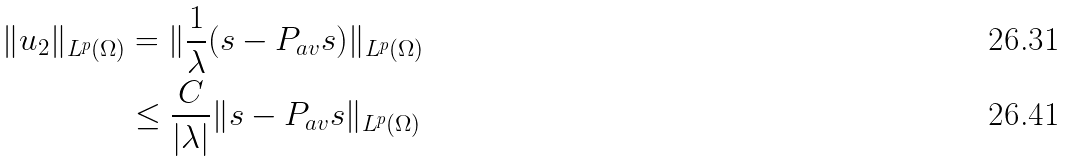<formula> <loc_0><loc_0><loc_500><loc_500>\| u _ { 2 } \| _ { L ^ { p } ( \Omega ) } & = \| \frac { 1 } { \lambda } ( s - P _ { a v } s ) \| _ { L ^ { p } ( \Omega ) } \\ & \leq \frac { C } { | \lambda | } \| s - P _ { a v } s \| _ { L ^ { p } ( \Omega ) }</formula> 